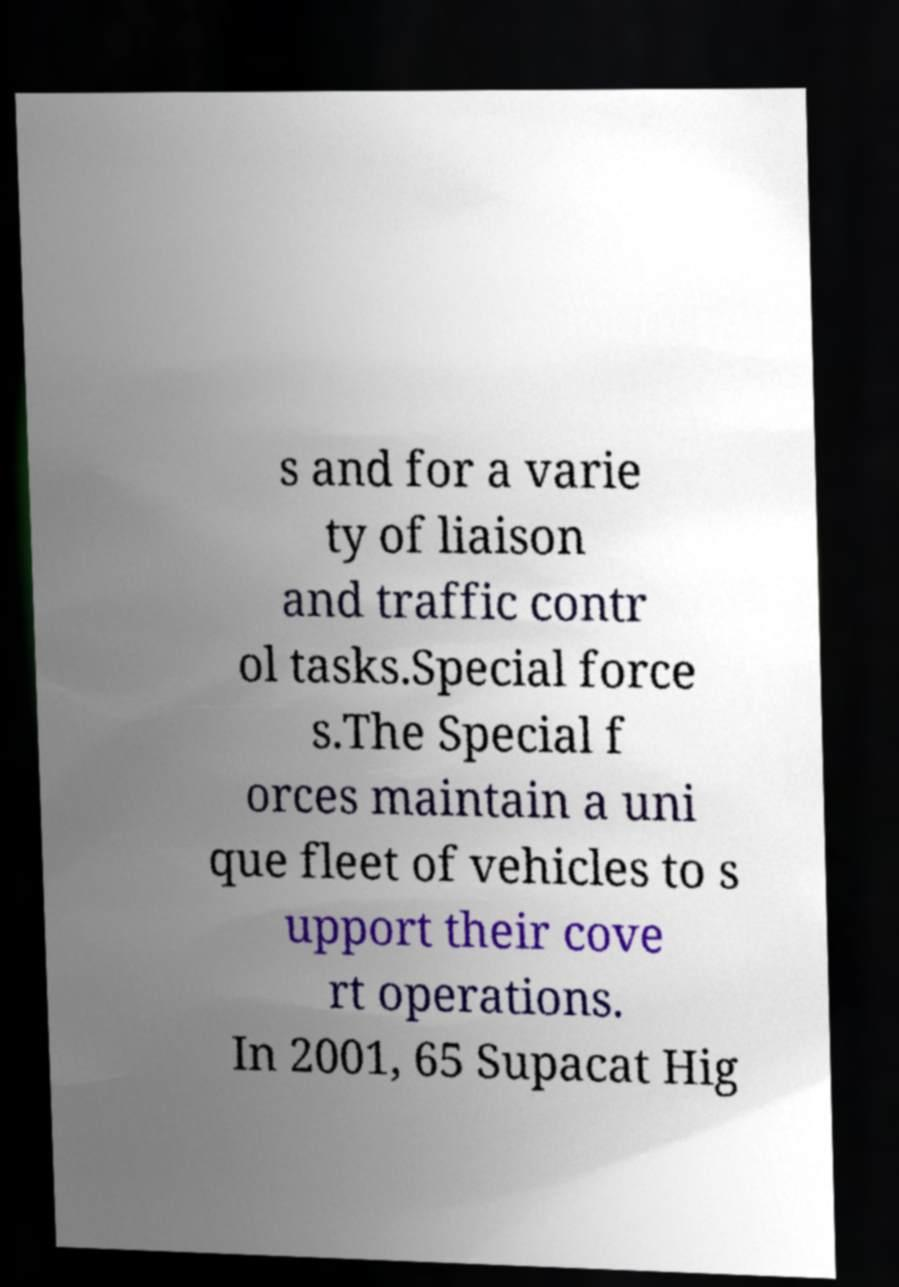Can you read and provide the text displayed in the image?This photo seems to have some interesting text. Can you extract and type it out for me? s and for a varie ty of liaison and traffic contr ol tasks.Special force s.The Special f orces maintain a uni que fleet of vehicles to s upport their cove rt operations. In 2001, 65 Supacat Hig 